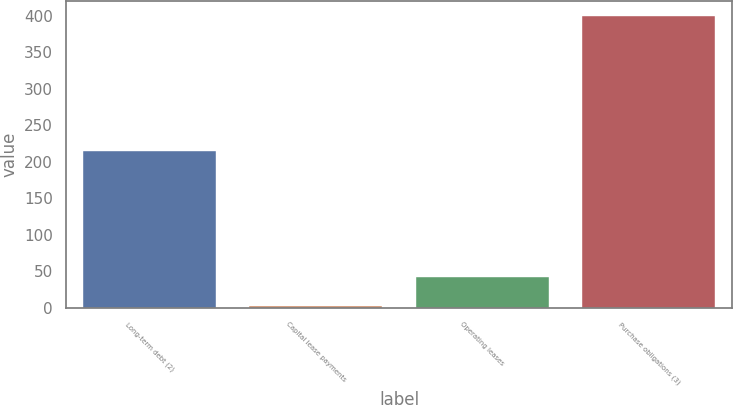Convert chart. <chart><loc_0><loc_0><loc_500><loc_500><bar_chart><fcel>Long-term debt (2)<fcel>Capital lease payments<fcel>Operating leases<fcel>Purchase obligations (3)<nl><fcel>214<fcel>3<fcel>42.7<fcel>400<nl></chart> 